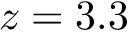Convert formula to latex. <formula><loc_0><loc_0><loc_500><loc_500>z = 3 . 3</formula> 